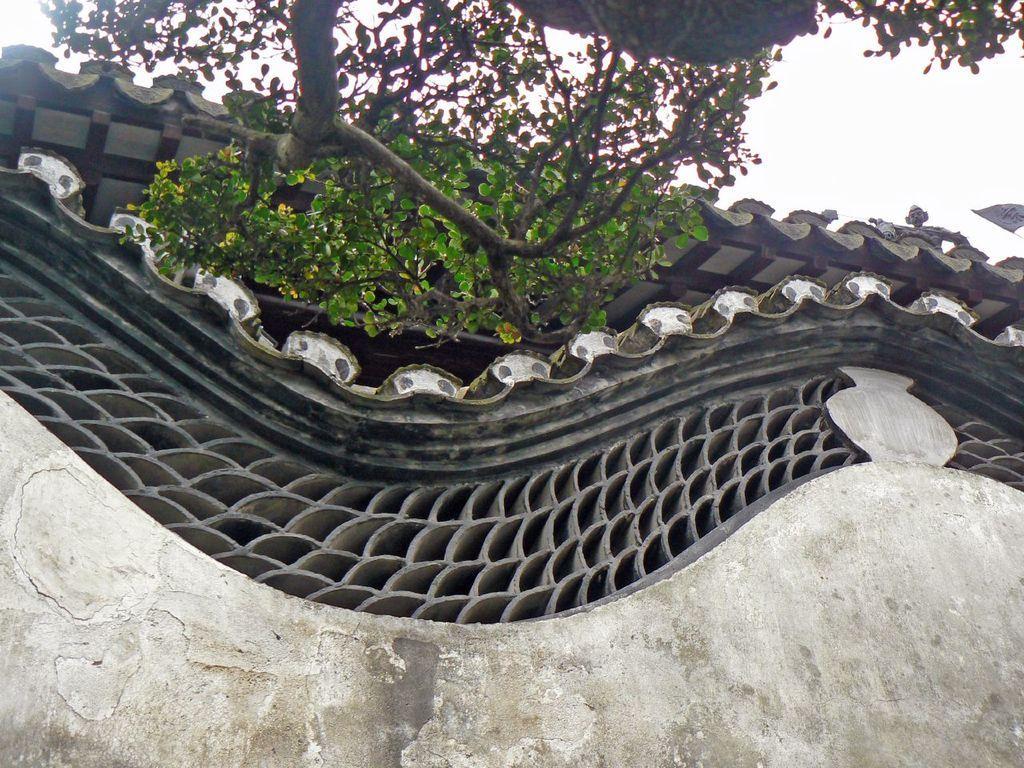Could you give a brief overview of what you see in this image? This picture shows a building and we see a tree and a cloudy sky. 